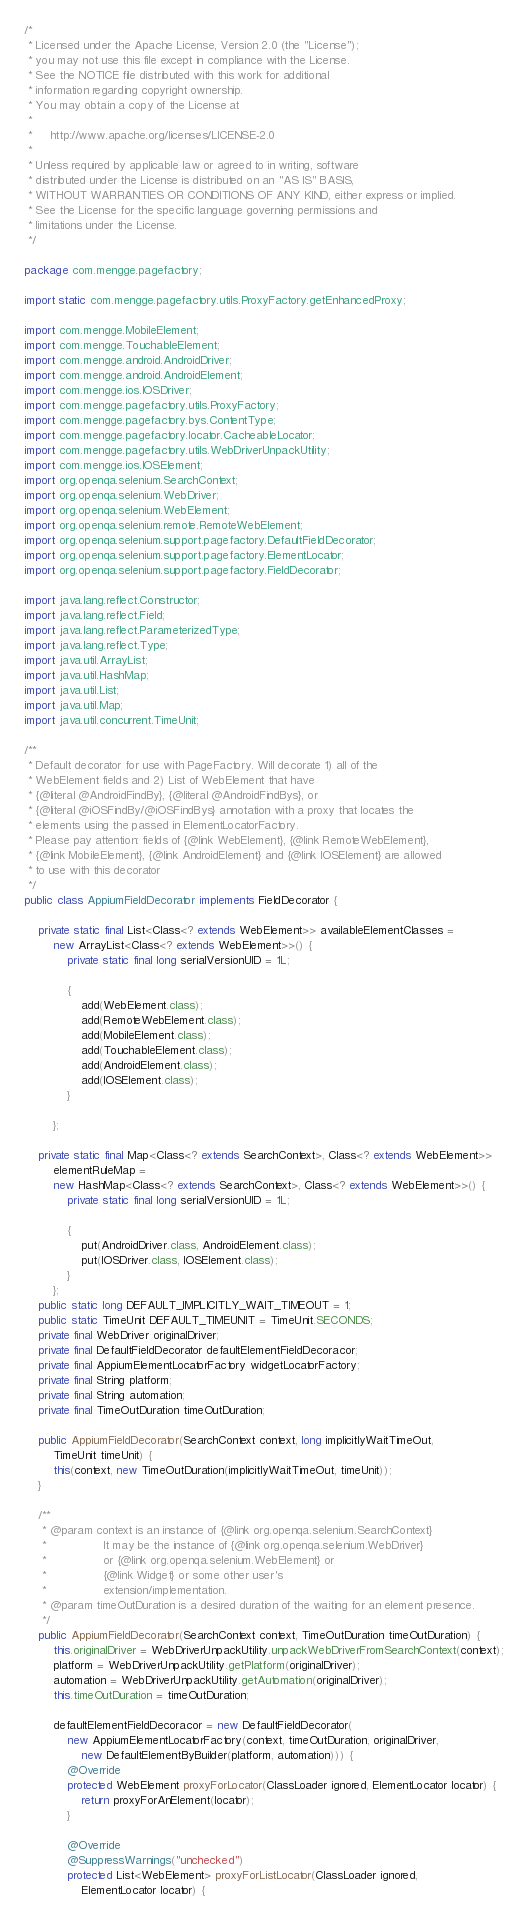Convert code to text. <code><loc_0><loc_0><loc_500><loc_500><_Java_>/*
 * Licensed under the Apache License, Version 2.0 (the "License");
 * you may not use this file except in compliance with the License.
 * See the NOTICE file distributed with this work for additional
 * information regarding copyright ownership.
 * You may obtain a copy of the License at
 *
 *     http://www.apache.org/licenses/LICENSE-2.0
 *
 * Unless required by applicable law or agreed to in writing, software
 * distributed under the License is distributed on an "AS IS" BASIS,
 * WITHOUT WARRANTIES OR CONDITIONS OF ANY KIND, either express or implied.
 * See the License for the specific language governing permissions and
 * limitations under the License.
 */

package com.mengge.pagefactory;

import static com.mengge.pagefactory.utils.ProxyFactory.getEnhancedProxy;

import com.mengge.MobileElement;
import com.mengge.TouchableElement;
import com.mengge.android.AndroidDriver;
import com.mengge.android.AndroidElement;
import com.mengge.ios.IOSDriver;
import com.mengge.pagefactory.utils.ProxyFactory;
import com.mengge.pagefactory.bys.ContentType;
import com.mengge.pagefactory.locator.CacheableLocator;
import com.mengge.pagefactory.utils.WebDriverUnpackUtility;
import com.mengge.ios.IOSElement;
import org.openqa.selenium.SearchContext;
import org.openqa.selenium.WebDriver;
import org.openqa.selenium.WebElement;
import org.openqa.selenium.remote.RemoteWebElement;
import org.openqa.selenium.support.pagefactory.DefaultFieldDecorator;
import org.openqa.selenium.support.pagefactory.ElementLocator;
import org.openqa.selenium.support.pagefactory.FieldDecorator;

import java.lang.reflect.Constructor;
import java.lang.reflect.Field;
import java.lang.reflect.ParameterizedType;
import java.lang.reflect.Type;
import java.util.ArrayList;
import java.util.HashMap;
import java.util.List;
import java.util.Map;
import java.util.concurrent.TimeUnit;

/**
 * Default decorator for use with PageFactory. Will decorate 1) all of the
 * WebElement fields and 2) List of WebElement that have
 * {@literal @AndroidFindBy}, {@literal @AndroidFindBys}, or
 * {@literal @iOSFindBy/@iOSFindBys} annotation with a proxy that locates the
 * elements using the passed in ElementLocatorFactory.
 * Please pay attention: fields of {@link WebElement}, {@link RemoteWebElement},
 * {@link MobileElement}, {@link AndroidElement} and {@link IOSElement} are allowed
 * to use with this decorator
 */
public class AppiumFieldDecorator implements FieldDecorator {

    private static final List<Class<? extends WebElement>> availableElementClasses =
        new ArrayList<Class<? extends WebElement>>() {
            private static final long serialVersionUID = 1L;

            {
                add(WebElement.class);
                add(RemoteWebElement.class);
                add(MobileElement.class);
                add(TouchableElement.class);
                add(AndroidElement.class);
                add(IOSElement.class);
            }

        };

    private static final Map<Class<? extends SearchContext>, Class<? extends WebElement>>
        elementRuleMap =
        new HashMap<Class<? extends SearchContext>, Class<? extends WebElement>>() {
            private static final long serialVersionUID = 1L;

            {
                put(AndroidDriver.class, AndroidElement.class);
                put(IOSDriver.class, IOSElement.class);
            }
        };
    public static long DEFAULT_IMPLICITLY_WAIT_TIMEOUT = 1;
    public static TimeUnit DEFAULT_TIMEUNIT = TimeUnit.SECONDS;
    private final WebDriver originalDriver;
    private final DefaultFieldDecorator defaultElementFieldDecoracor;
    private final AppiumElementLocatorFactory widgetLocatorFactory;
    private final String platform;
    private final String automation;
    private final TimeOutDuration timeOutDuration;

    public AppiumFieldDecorator(SearchContext context, long implicitlyWaitTimeOut,
        TimeUnit timeUnit) {
        this(context, new TimeOutDuration(implicitlyWaitTimeOut, timeUnit));
    }

    /**
     * @param context is an instance of {@link org.openqa.selenium.SearchContext}
     *                It may be the instance of {@link org.openqa.selenium.WebDriver}
     *                or {@link org.openqa.selenium.WebElement} or
     *                {@link Widget} or some other user's
     *                extension/implementation.
     * @param timeOutDuration is a desired duration of the waiting for an element presence.
     */
    public AppiumFieldDecorator(SearchContext context, TimeOutDuration timeOutDuration) {
        this.originalDriver = WebDriverUnpackUtility.unpackWebDriverFromSearchContext(context);
        platform = WebDriverUnpackUtility.getPlatform(originalDriver);
        automation = WebDriverUnpackUtility.getAutomation(originalDriver);
        this.timeOutDuration = timeOutDuration;

        defaultElementFieldDecoracor = new DefaultFieldDecorator(
            new AppiumElementLocatorFactory(context, timeOutDuration, originalDriver,
                new DefaultElementByBuilder(platform, automation))) {
            @Override
            protected WebElement proxyForLocator(ClassLoader ignored, ElementLocator locator) {
                return proxyForAnElement(locator);
            }

            @Override
            @SuppressWarnings("unchecked")
            protected List<WebElement> proxyForListLocator(ClassLoader ignored,
                ElementLocator locator) {</code> 